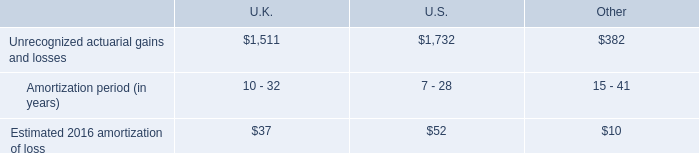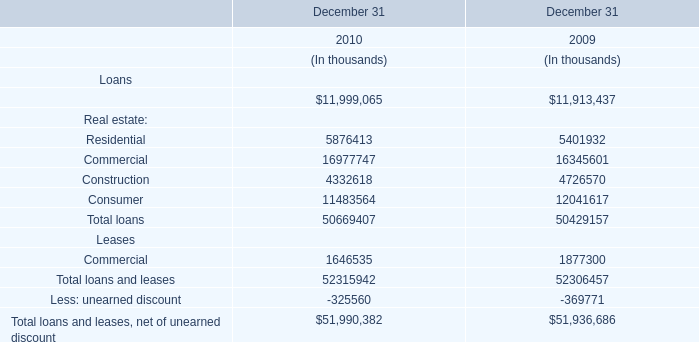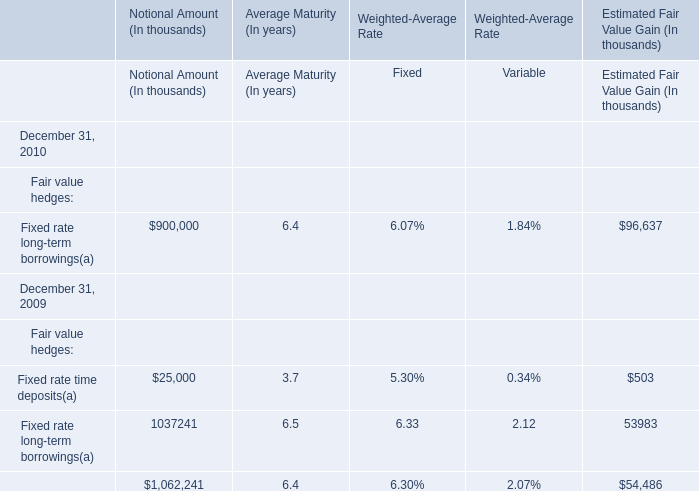in 2015 what was the ratio of the unrecognized prior service cost to the income 
Computations: (7 / (9 + 46))
Answer: 0.12727. 